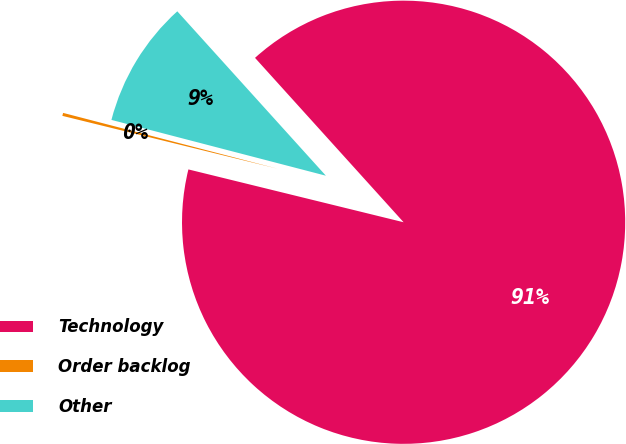Convert chart to OTSL. <chart><loc_0><loc_0><loc_500><loc_500><pie_chart><fcel>Technology<fcel>Order backlog<fcel>Other<nl><fcel>90.52%<fcel>0.22%<fcel>9.25%<nl></chart> 